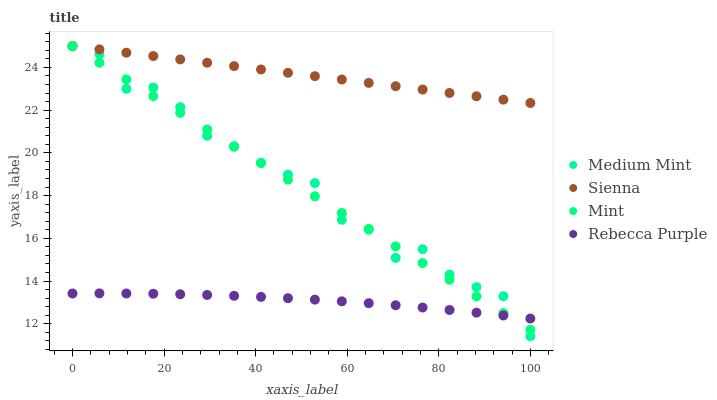Does Rebecca Purple have the minimum area under the curve?
Answer yes or no. Yes. Does Sienna have the maximum area under the curve?
Answer yes or no. Yes. Does Mint have the minimum area under the curve?
Answer yes or no. No. Does Mint have the maximum area under the curve?
Answer yes or no. No. Is Sienna the smoothest?
Answer yes or no. Yes. Is Medium Mint the roughest?
Answer yes or no. Yes. Is Mint the smoothest?
Answer yes or no. No. Is Mint the roughest?
Answer yes or no. No. Does Medium Mint have the lowest value?
Answer yes or no. Yes. Does Mint have the lowest value?
Answer yes or no. No. Does Mint have the highest value?
Answer yes or no. Yes. Does Rebecca Purple have the highest value?
Answer yes or no. No. Is Medium Mint less than Sienna?
Answer yes or no. Yes. Is Sienna greater than Medium Mint?
Answer yes or no. Yes. Does Rebecca Purple intersect Medium Mint?
Answer yes or no. Yes. Is Rebecca Purple less than Medium Mint?
Answer yes or no. No. Is Rebecca Purple greater than Medium Mint?
Answer yes or no. No. Does Medium Mint intersect Sienna?
Answer yes or no. No. 